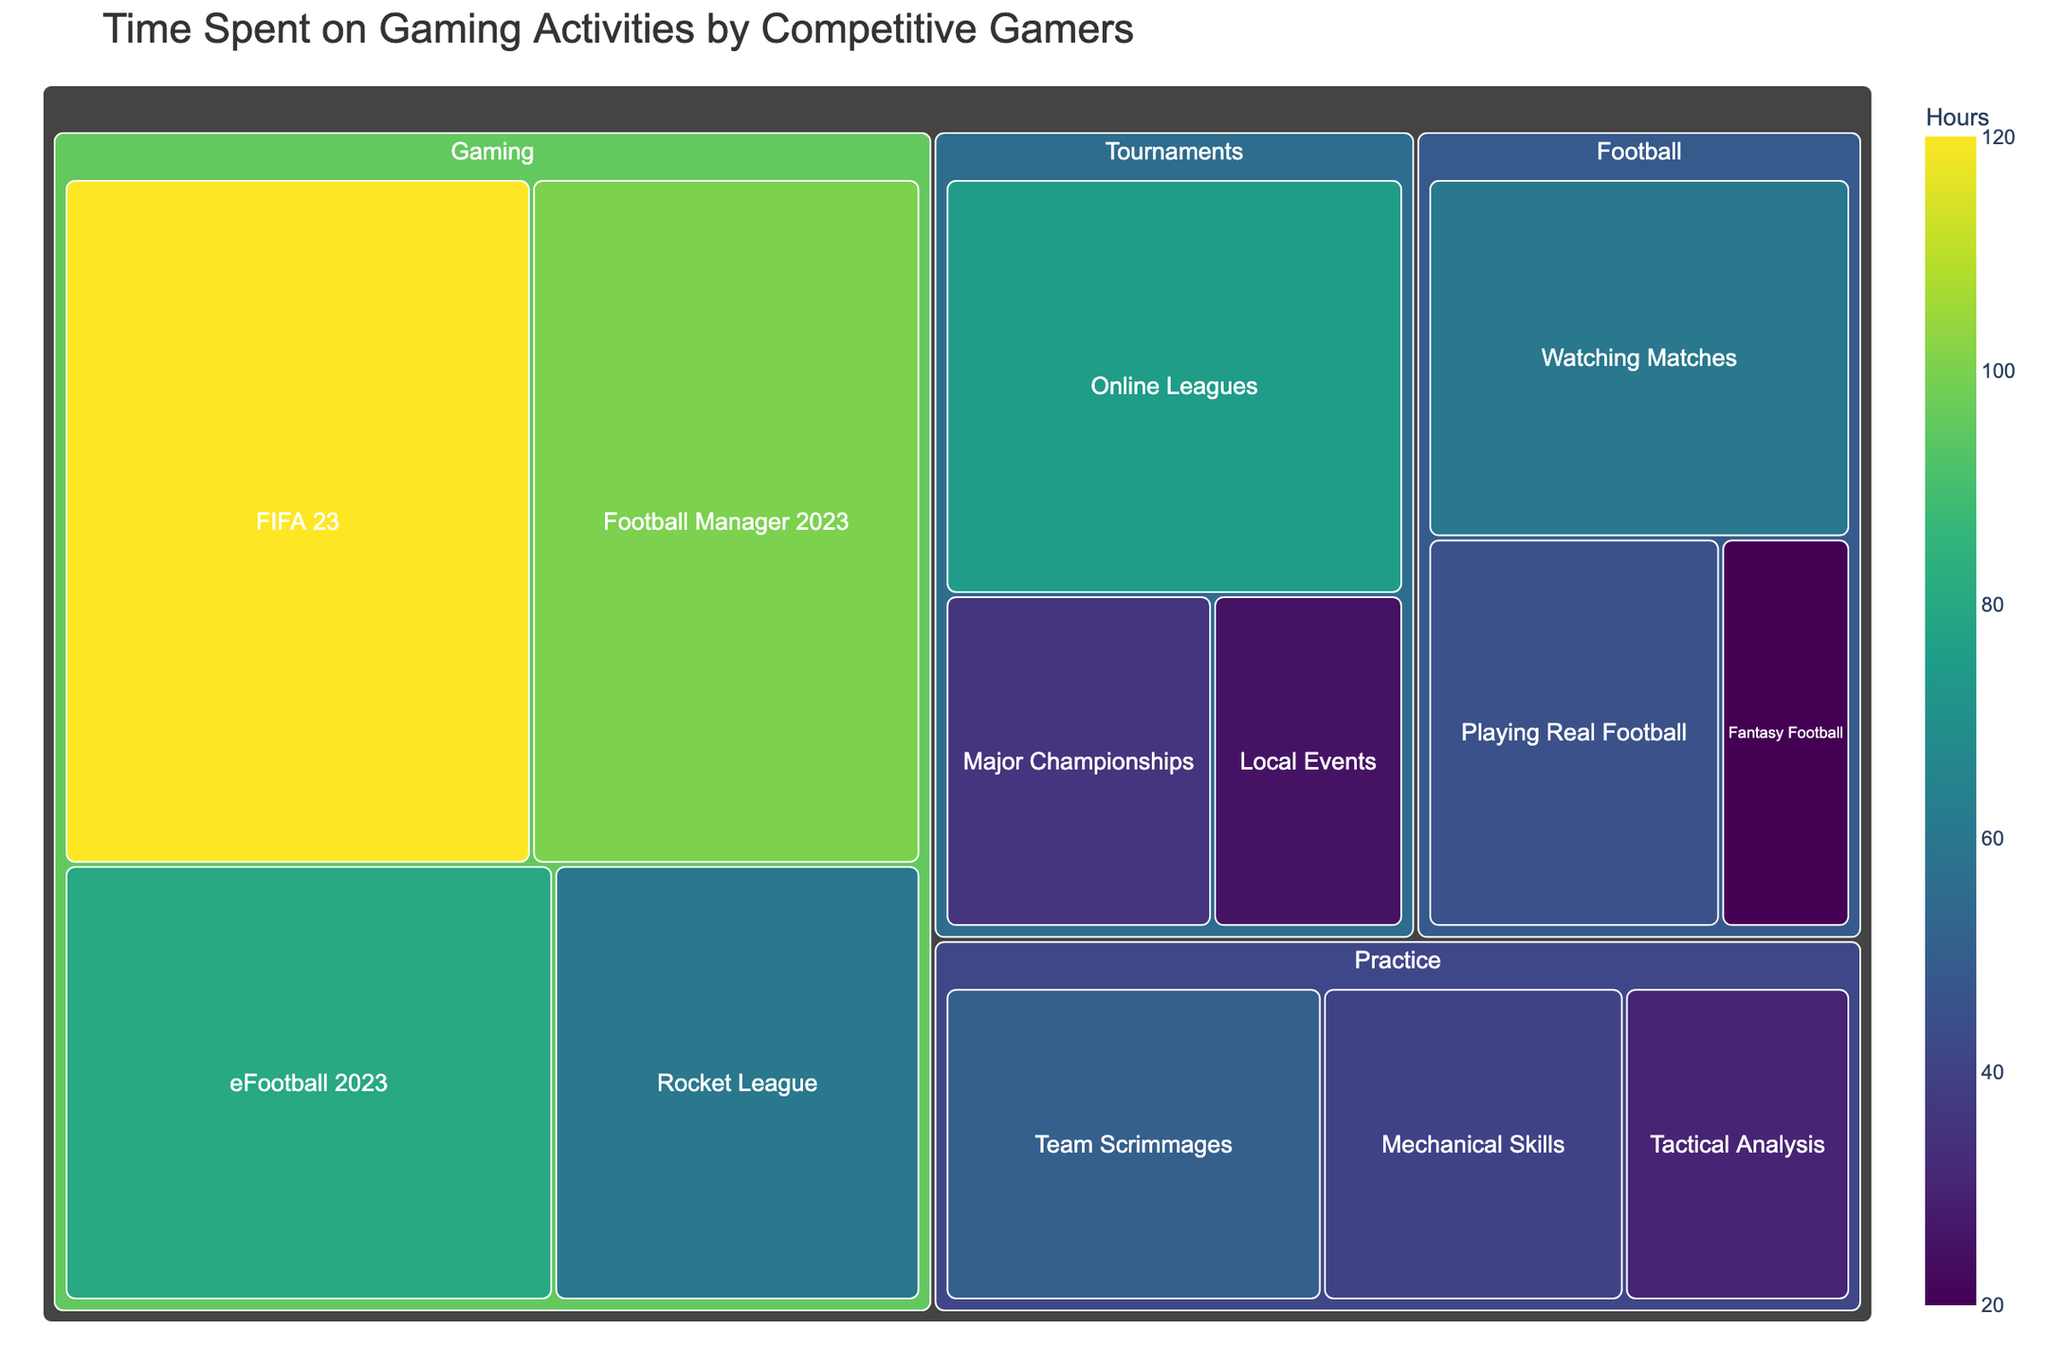What is the title of the figure? The title is displayed at the top of the treemap and provides a summary of what the figure represents.
Answer: Time Spent on Gaming Activities by Competitive Gamers Which subcategory in the Gaming category has the most hours? The Gaming category contains four subcategories, and the one with the largest tile, indicating the most hours, is the answer.
Answer: FIFA 23 How many hours are spent on Practice activities in total? Add the hours from all subcategories under Practice. Sum of Mechanical Skills (40), Tactical Analysis (30), and Team Scrimmages (50).
Answer: 120 What is the difference in hours between Playing Real Football and Fantasy Football? Look at the hours for Playing Real Football (45) and Fantasy Football (20) and subtract the smaller from the larger.
Answer: 25 Which subcategory has the least number of hours overall? Locate the smallest tile across all categories, indicating the fewest hours.
Answer: Fantasy Football Which activity in the Tournaments category has the highest time spent? Compare the size of the tiles in the Tournaments category. The largest tile represents the subcategory with the most hours.
Answer: Online Leagues Are there more hours spent on Major Championships or Team Scrimmages? Compare the hours between the subcategory under Tournaments (Major Championships: 35) and Practice (Team Scrimmages: 50).
Answer: Team Scrimmages What is the total time spent on Football-related activities? Sum the hours from all subcategories under Football. Watching Matches (60) + Playing Real Football (45) + Fantasy Football (20).
Answer: 125 How do the hours spent on Football Manager 2023 compare to those on Rocket League? Check the hours for Football Manager 2023 (100) and Rocket League (60) to see which is greater.
Answer: Football Manager 2023 What is the combined time spent on watching and playing real football? Add the hours for Watching Matches (60) and Playing Real Football (45).
Answer: 105 